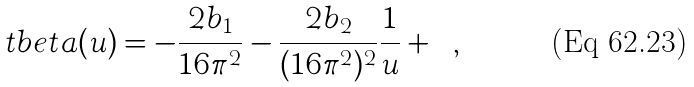<formula> <loc_0><loc_0><loc_500><loc_500>\ t b e t a ( u ) = - \frac { 2 b _ { 1 } } { 1 6 \pi ^ { 2 } } - \frac { 2 b _ { 2 } } { ( 1 6 \pi ^ { 2 } ) ^ { 2 } } \frac { 1 } { u } + \cdots ,</formula> 